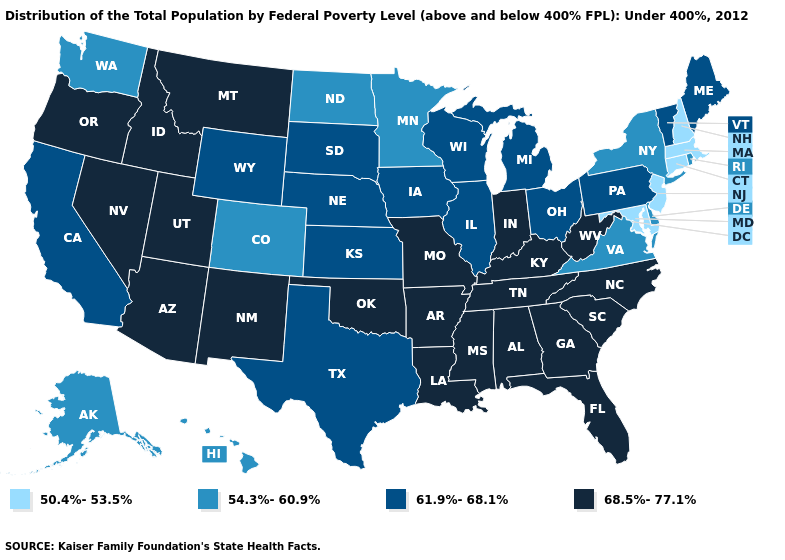Name the states that have a value in the range 68.5%-77.1%?
Concise answer only. Alabama, Arizona, Arkansas, Florida, Georgia, Idaho, Indiana, Kentucky, Louisiana, Mississippi, Missouri, Montana, Nevada, New Mexico, North Carolina, Oklahoma, Oregon, South Carolina, Tennessee, Utah, West Virginia. Which states hav the highest value in the South?
Write a very short answer. Alabama, Arkansas, Florida, Georgia, Kentucky, Louisiana, Mississippi, North Carolina, Oklahoma, South Carolina, Tennessee, West Virginia. Among the states that border Utah , which have the lowest value?
Short answer required. Colorado. What is the value of Tennessee?
Short answer required. 68.5%-77.1%. Does the first symbol in the legend represent the smallest category?
Answer briefly. Yes. What is the value of Massachusetts?
Answer briefly. 50.4%-53.5%. What is the value of Montana?
Short answer required. 68.5%-77.1%. What is the value of Texas?
Quick response, please. 61.9%-68.1%. What is the value of New Jersey?
Quick response, please. 50.4%-53.5%. What is the value of Oklahoma?
Concise answer only. 68.5%-77.1%. What is the value of Minnesota?
Concise answer only. 54.3%-60.9%. Does Pennsylvania have a lower value than Rhode Island?
Give a very brief answer. No. What is the lowest value in states that border Tennessee?
Answer briefly. 54.3%-60.9%. Name the states that have a value in the range 61.9%-68.1%?
Keep it brief. California, Illinois, Iowa, Kansas, Maine, Michigan, Nebraska, Ohio, Pennsylvania, South Dakota, Texas, Vermont, Wisconsin, Wyoming. Among the states that border Montana , which have the lowest value?
Concise answer only. North Dakota. 